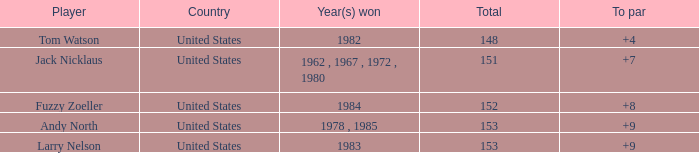What is the combined score of a player who has a 4 "to par" status? 1.0. 